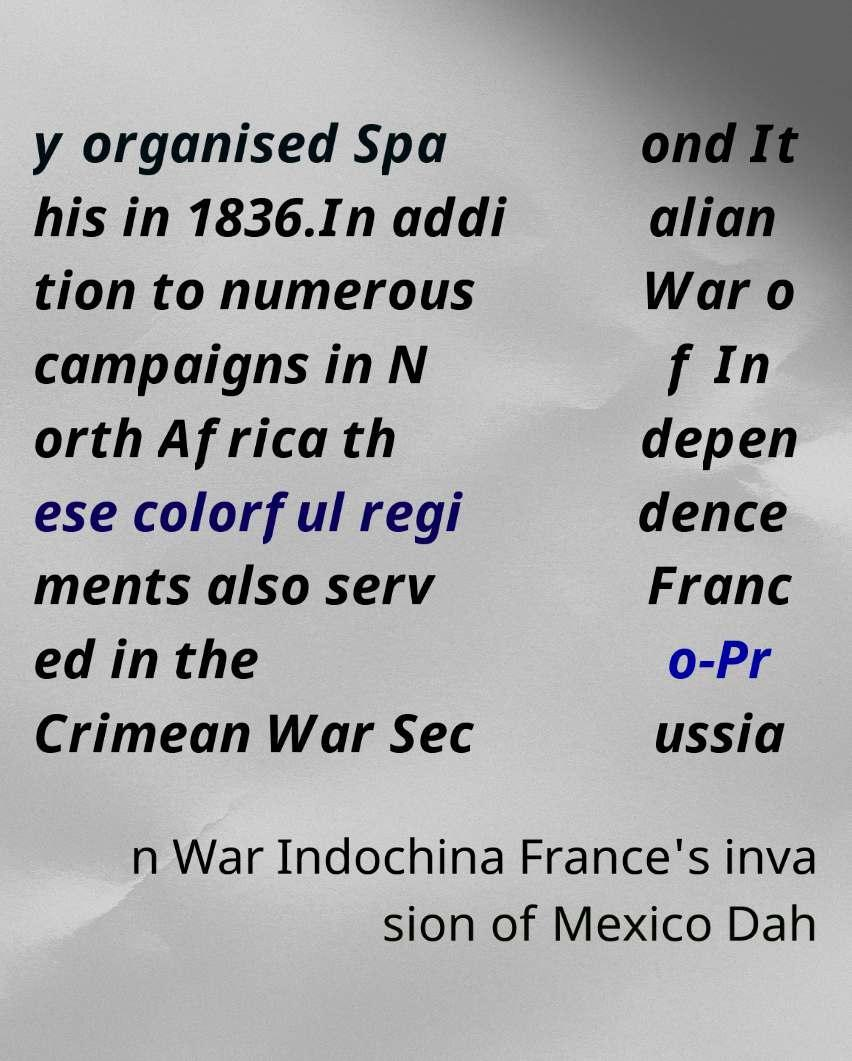What messages or text are displayed in this image? I need them in a readable, typed format. y organised Spa his in 1836.In addi tion to numerous campaigns in N orth Africa th ese colorful regi ments also serv ed in the Crimean War Sec ond It alian War o f In depen dence Franc o-Pr ussia n War Indochina France's inva sion of Mexico Dah 